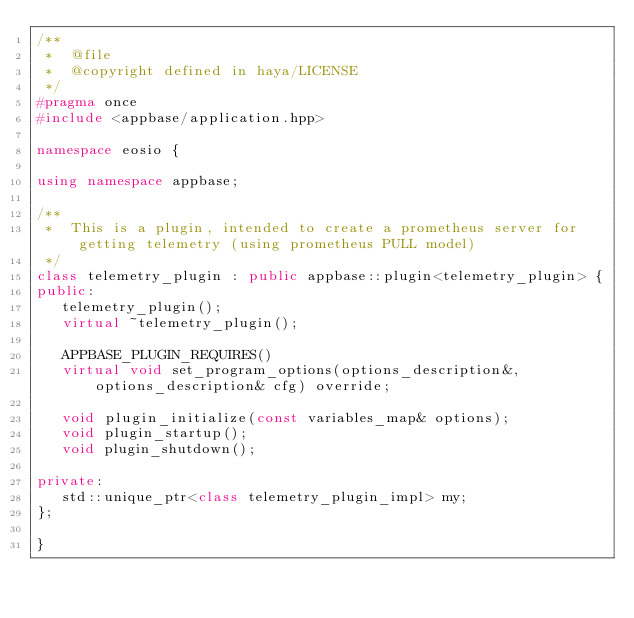Convert code to text. <code><loc_0><loc_0><loc_500><loc_500><_C++_>/**
 *  @file
 *  @copyright defined in haya/LICENSE
 */
#pragma once
#include <appbase/application.hpp>

namespace eosio {

using namespace appbase;

/**
 *  This is a plugin, intended to create a prometheus server for getting telemetry (using prometheus PULL model)
 */
class telemetry_plugin : public appbase::plugin<telemetry_plugin> {
public:
   telemetry_plugin();
   virtual ~telemetry_plugin();

   APPBASE_PLUGIN_REQUIRES()
   virtual void set_program_options(options_description&, options_description& cfg) override;

   void plugin_initialize(const variables_map& options);
   void plugin_startup();
   void plugin_shutdown();

private:
   std::unique_ptr<class telemetry_plugin_impl> my;
};

}
</code> 